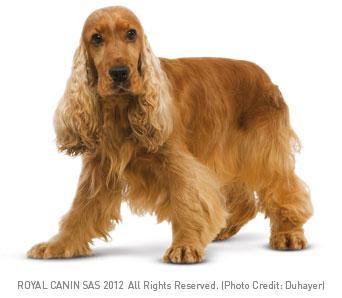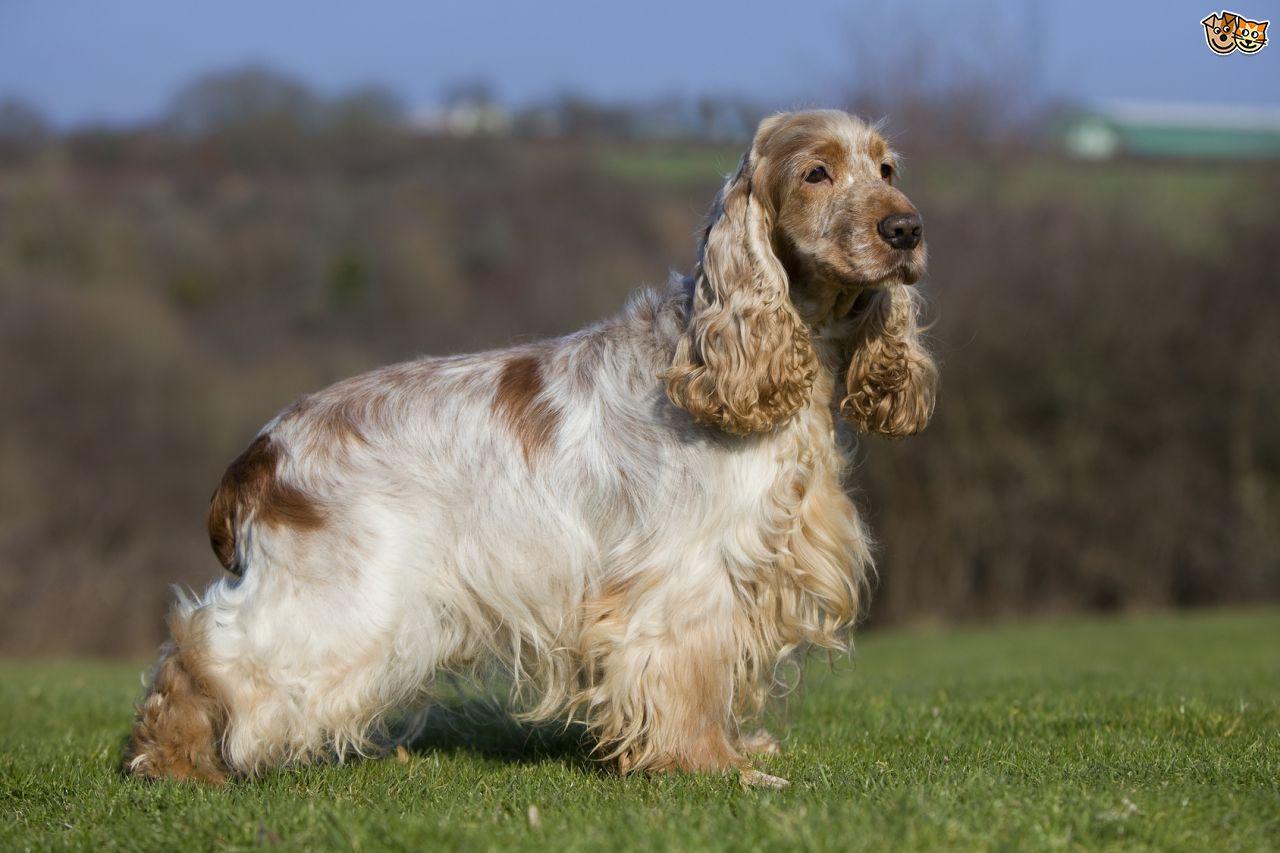The first image is the image on the left, the second image is the image on the right. Evaluate the accuracy of this statement regarding the images: "One image has a colored background, while the other is white, they are not the same.". Is it true? Answer yes or no. Yes. 